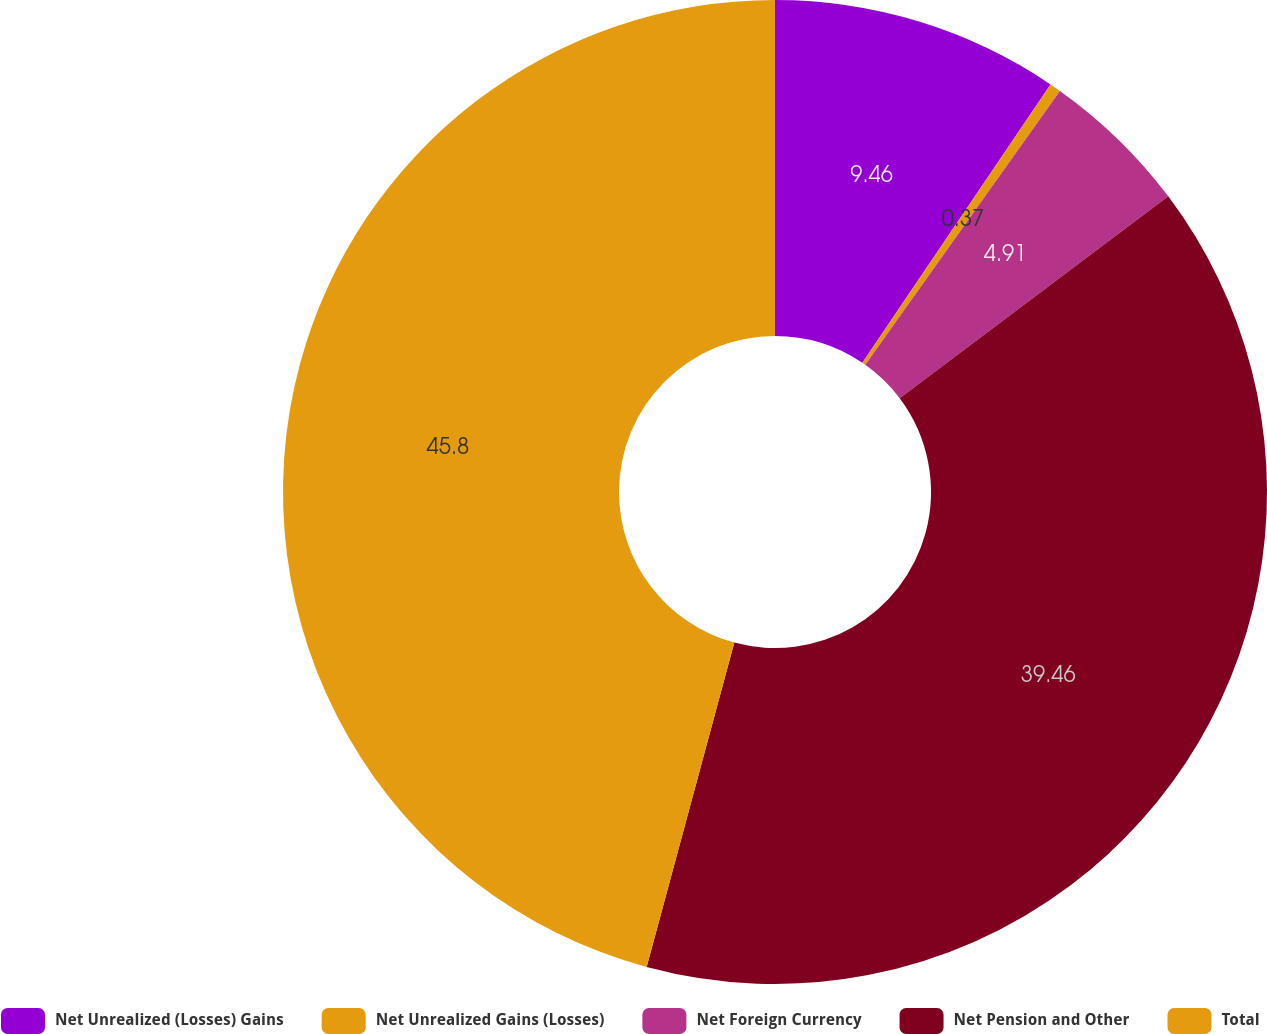<chart> <loc_0><loc_0><loc_500><loc_500><pie_chart><fcel>Net Unrealized (Losses) Gains<fcel>Net Unrealized Gains (Losses)<fcel>Net Foreign Currency<fcel>Net Pension and Other<fcel>Total<nl><fcel>9.46%<fcel>0.37%<fcel>4.91%<fcel>39.46%<fcel>45.8%<nl></chart> 